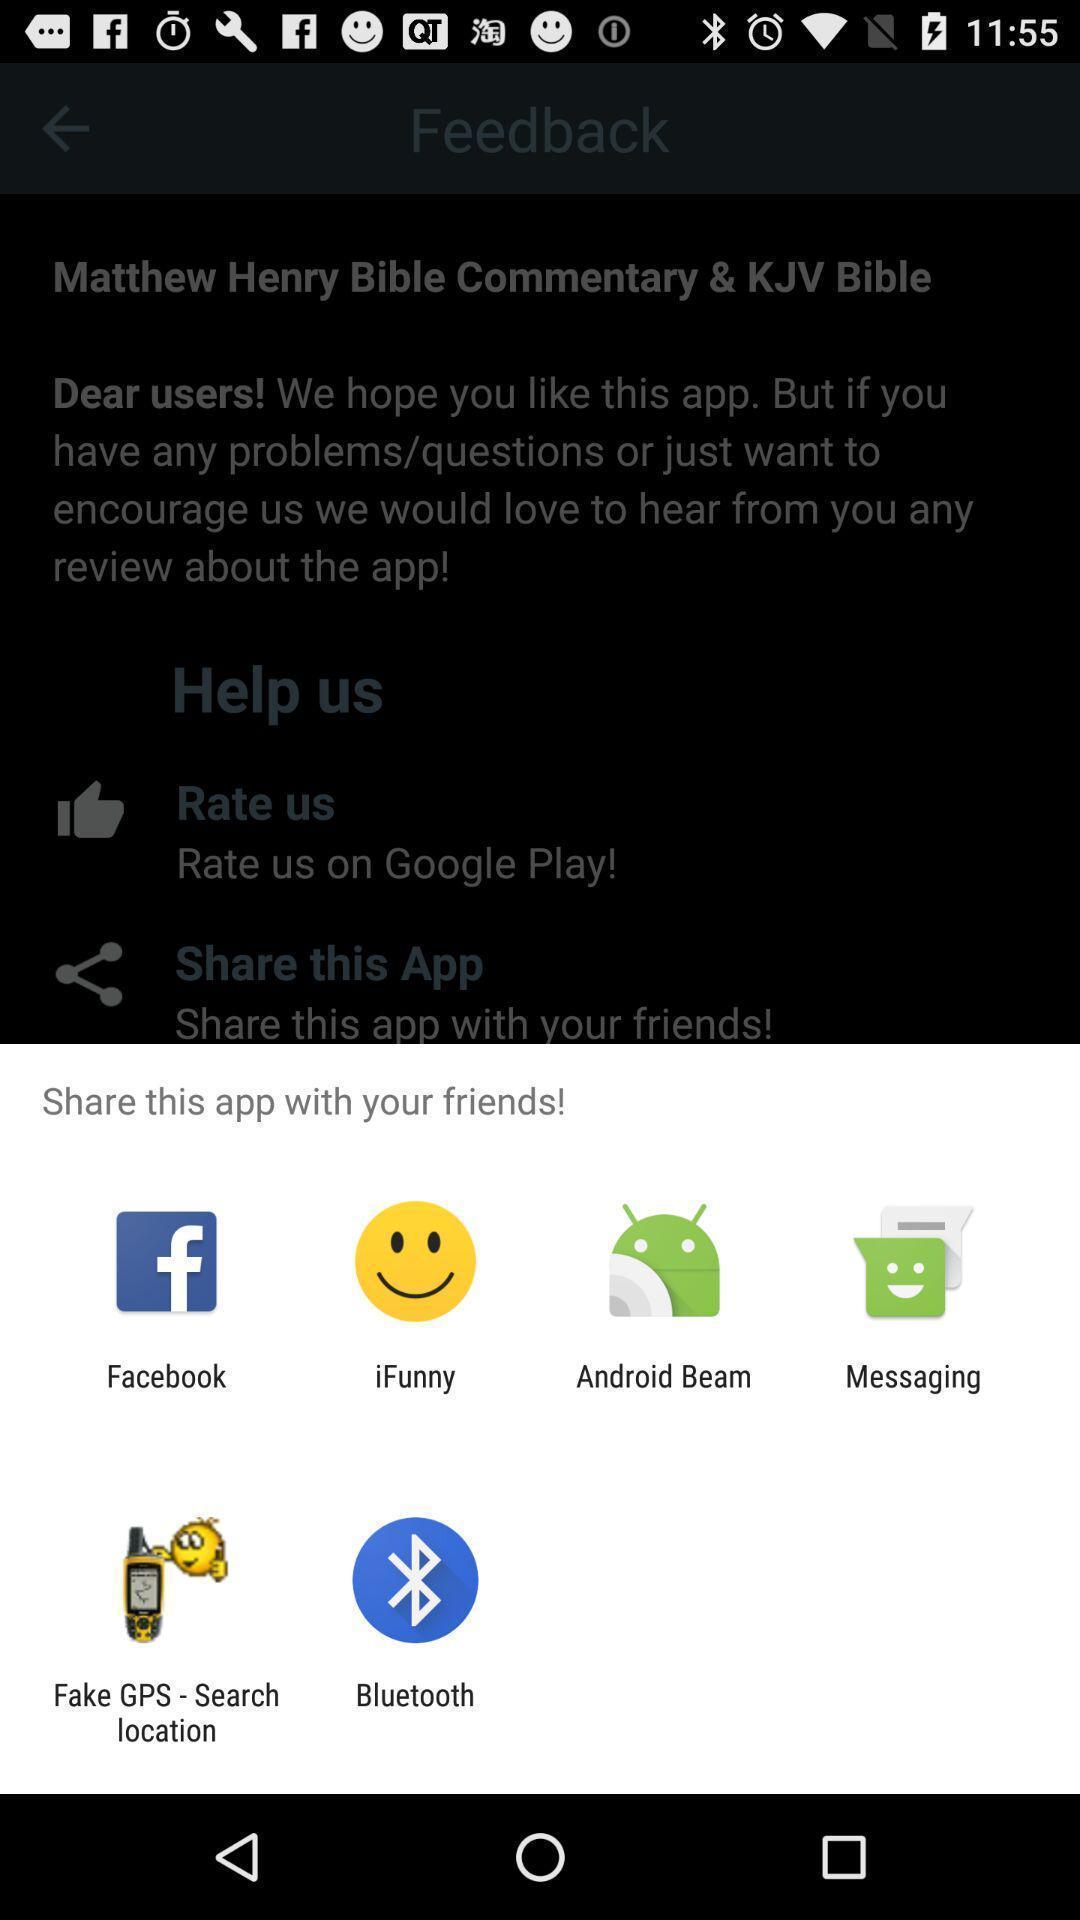Describe the content in this image. Screen displaying sharing options using different social applications. 